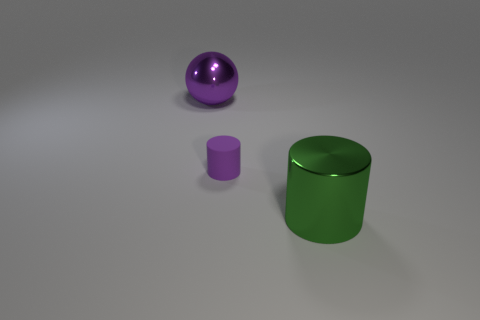What material is the tiny cylinder that is the same color as the metallic sphere?
Your response must be concise. Rubber. Is the big purple ball made of the same material as the big green cylinder?
Keep it short and to the point. Yes. What number of small things are in front of the tiny purple rubber cylinder?
Your answer should be very brief. 0. There is a object that is behind the green cylinder and in front of the ball; what material is it?
Provide a succinct answer. Rubber. What number of metal balls have the same size as the green shiny cylinder?
Keep it short and to the point. 1. What is the color of the large object left of the purple thing right of the big metallic ball?
Provide a short and direct response. Purple. Are there any big shiny objects?
Your response must be concise. Yes. Is the shape of the green object the same as the tiny rubber object?
Your answer should be compact. Yes. What is the size of the metal object that is the same color as the small rubber cylinder?
Keep it short and to the point. Large. How many tiny matte things are on the left side of the purple thing on the right side of the big metallic sphere?
Keep it short and to the point. 0. 